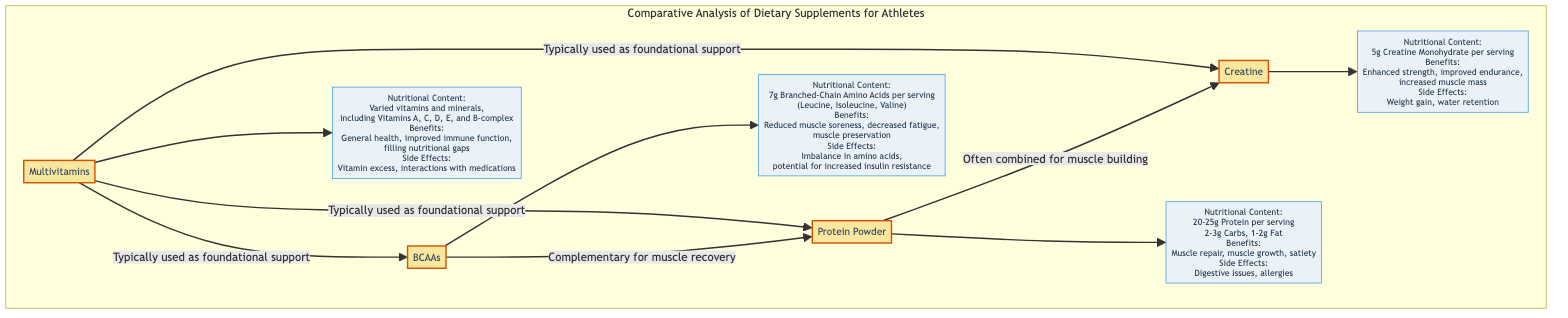What is the protein content per serving of protein powder? The protein powder node connects to the nutritional content node, which specifies that it contains 20-25g of protein per serving.
Answer: 20-25g What are the potential side effects of creatine? The creatine node connects to its nutritional content node, where it lists the side effects. These include weight gain and water retention.
Answer: Weight gain, water retention How many supplements are compared in the diagram? Counting the supplement nodes in the diagram reveals that there are four: protein powder, creatine, BCAAs, and multivitamins.
Answer: Four Which supplement is indicated as typically used for foundational support? The diagram shows arrows pointing from the multivitamin node to the protein powder, creatine, and BCAAs nodes, indicating that multivitamins are typically used for foundational support.
Answer: Multivitamins What is one benefit of BCAAs? The BCAAs node directs to its nutritional content, where at least one benefit listed is reduced muscle soreness.
Answer: Reduced muscle soreness What connections exist between protein powder and BCAAs? The diagram shows a direct arrow from the BCAAs node to the protein powder node, indicating that BCAAs are complementary for muscle recovery with protein powder.
Answer: Complementary for muscle recovery What is the number of vitamins and minerals included in multivitamins? The multivitamins nutritional content node states that they contain varied vitamins and minerals, including Vitamins A, C, D, E, and B-complex, but does not specify a total number. Therefore, we can’t provide a precise figure.
Answer: Varied What is a common side effect of multivitamins? The multivitamin node refers to its nutritional content, where it notes that one side effect can be vitamin excess.
Answer: Vitamin excess 